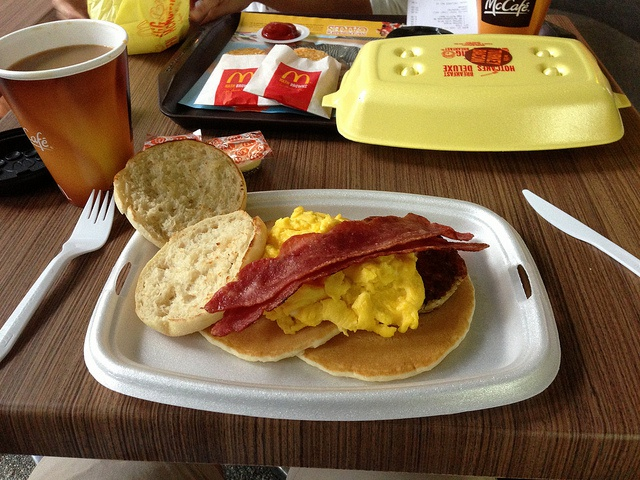Describe the objects in this image and their specific colors. I can see dining table in black, maroon, darkgray, and khaki tones, cup in gray, maroon, brown, and darkgray tones, fork in gray, lightgray, and darkgray tones, cup in gray, black, brown, maroon, and darkgray tones, and knife in gray, lightgray, and maroon tones in this image. 